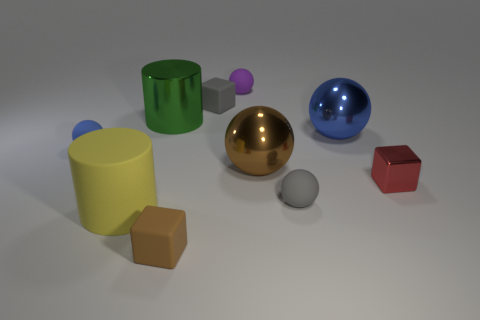How does the lighting in the image affect the appearance of the objects? The lighting creates soft shadows and subtle reflections, which enhance the three-dimensional qualities of the objects and provide a sense of depth in the scene.  Can you describe the atmosphere or mood conveyed by the image? The image has a calm and composed mood, with neutral background colors and soft lighting. It gives off a clean and minimalistic vibe, which is often associated with modern design aesthetics. 